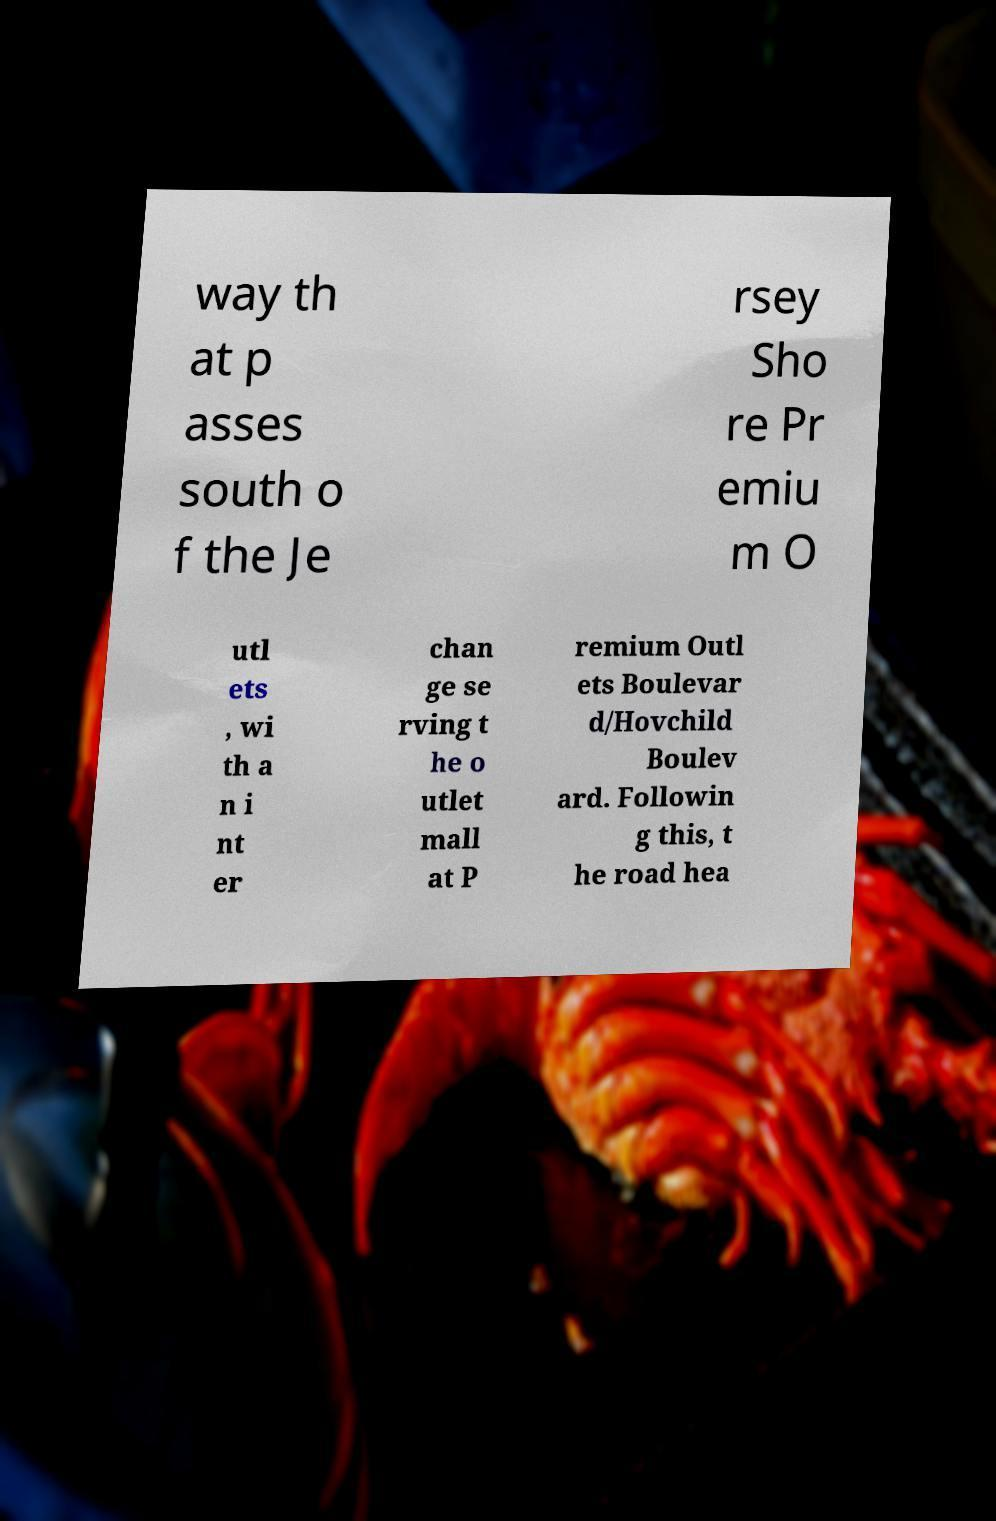Can you read and provide the text displayed in the image?This photo seems to have some interesting text. Can you extract and type it out for me? way th at p asses south o f the Je rsey Sho re Pr emiu m O utl ets , wi th a n i nt er chan ge se rving t he o utlet mall at P remium Outl ets Boulevar d/Hovchild Boulev ard. Followin g this, t he road hea 